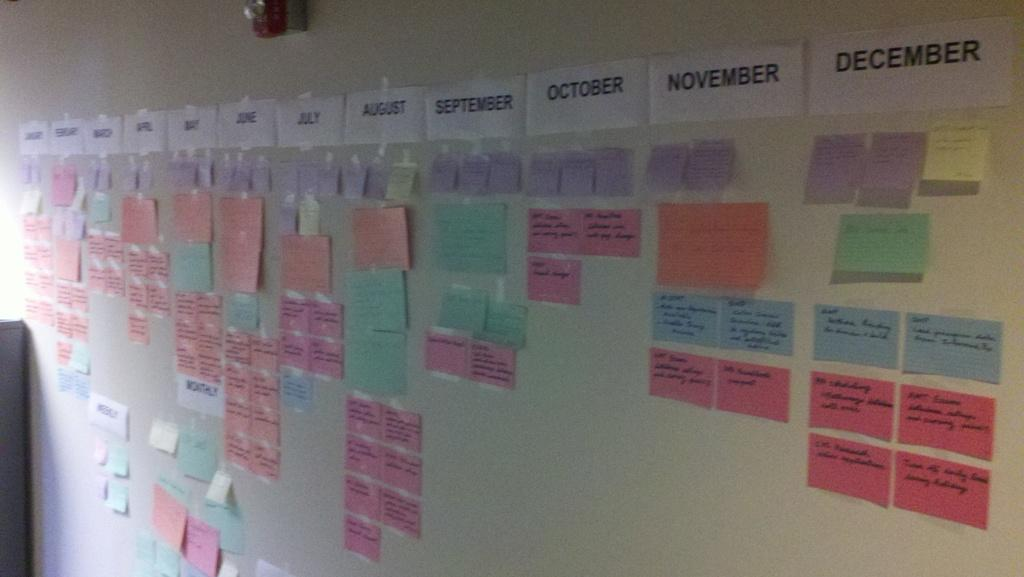<image>
Summarize the visual content of the image. A  whiteboard with colorful stickers and the month December at the top right. 